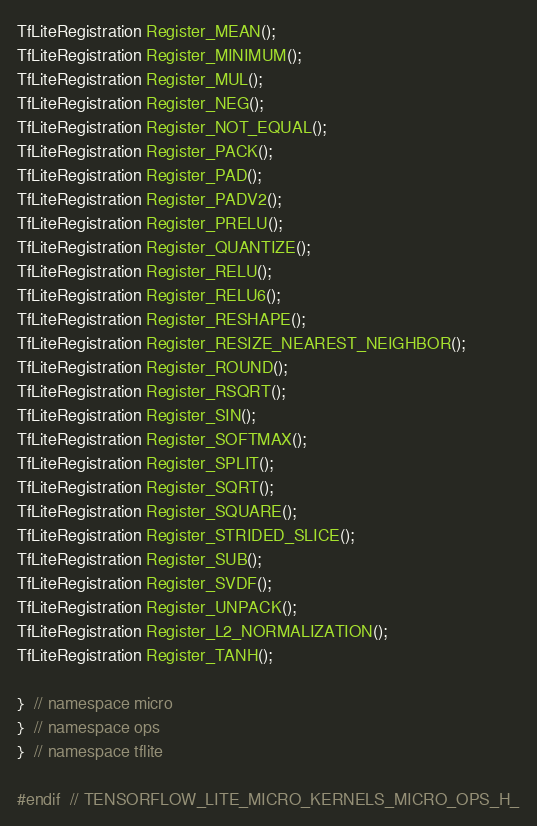Convert code to text. <code><loc_0><loc_0><loc_500><loc_500><_C_>TfLiteRegistration Register_MEAN();
TfLiteRegistration Register_MINIMUM();
TfLiteRegistration Register_MUL();
TfLiteRegistration Register_NEG();
TfLiteRegistration Register_NOT_EQUAL();
TfLiteRegistration Register_PACK();
TfLiteRegistration Register_PAD();
TfLiteRegistration Register_PADV2();
TfLiteRegistration Register_PRELU();
TfLiteRegistration Register_QUANTIZE();
TfLiteRegistration Register_RELU();
TfLiteRegistration Register_RELU6();
TfLiteRegistration Register_RESHAPE();
TfLiteRegistration Register_RESIZE_NEAREST_NEIGHBOR();
TfLiteRegistration Register_ROUND();
TfLiteRegistration Register_RSQRT();
TfLiteRegistration Register_SIN();
TfLiteRegistration Register_SOFTMAX();
TfLiteRegistration Register_SPLIT();
TfLiteRegistration Register_SQRT();
TfLiteRegistration Register_SQUARE();
TfLiteRegistration Register_STRIDED_SLICE();
TfLiteRegistration Register_SUB();
TfLiteRegistration Register_SVDF();
TfLiteRegistration Register_UNPACK();
TfLiteRegistration Register_L2_NORMALIZATION();
TfLiteRegistration Register_TANH();

}  // namespace micro
}  // namespace ops
}  // namespace tflite

#endif  // TENSORFLOW_LITE_MICRO_KERNELS_MICRO_OPS_H_
</code> 